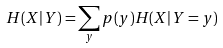<formula> <loc_0><loc_0><loc_500><loc_500>H ( X | Y ) = \sum _ { y } { p ( y ) H ( X | Y = y ) }</formula> 